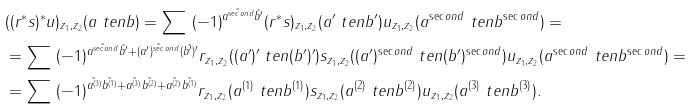<formula> <loc_0><loc_0><loc_500><loc_500>& ( ( r ^ { * } s ) ^ { * } u ) _ { z _ { 1 } , z _ { 2 } } ( a \ t e n b ) = \sum \ ( - 1 ) ^ { \tilde { a ^ { \sec o n d } } \tilde { b ^ { \prime } } } ( r ^ { * } s ) _ { z _ { 1 } , z _ { 2 } } ( a ^ { \prime } \ t e n b ^ { \prime } ) u _ { z _ { 1 } , z _ { 2 } } ( a ^ { \sec o n d } \ t e n b ^ { \sec o n d } ) = \\ & = \sum \ ( - 1 ) ^ { \tilde { a ^ { \sec o n d } } \tilde { b ^ { \prime } } + \tilde { ( a ^ { \prime } ) ^ { \sec o n d } } \tilde { ( b ^ { \prime } ) ^ { \prime } } } r _ { z _ { 1 } , z _ { 2 } } ( ( a ^ { \prime } ) ^ { \prime } \ t e n ( b ^ { \prime } ) ^ { \prime } ) s _ { z _ { 1 } , z _ { 2 } } ( ( a ^ { \prime } ) ^ { \sec o n d } \ t e n ( b ^ { \prime } ) ^ { \sec o n d } ) u _ { z _ { 1 } , z _ { 2 } } ( a ^ { \sec o n d } \ t e n b ^ { \sec o n d } ) = \\ & = \sum \ ( - 1 ) ^ { \tilde { a ^ { ( 3 ) } } \tilde { b ^ { ( 1 ) } } + \tilde { a ^ { ( 3 ) } } \tilde { b ^ { ( 2 ) } } + \tilde { a ^ { ( 2 ) } } \tilde { b ^ { ( 1 ) } } } r _ { z _ { 1 } , z _ { 2 } } ( a ^ { ( 1 ) } \ t e n b ^ { ( 1 ) } ) s _ { z _ { 1 } , z _ { 2 } } ( a ^ { ( 2 ) } \ t e n b ^ { ( 2 ) } ) u _ { z _ { 1 } , z _ { 2 } } ( a ^ { ( 3 ) } \ t e n b ^ { ( 3 ) } ) .</formula> 